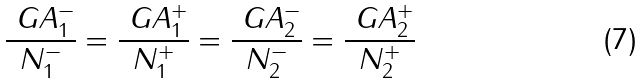Convert formula to latex. <formula><loc_0><loc_0><loc_500><loc_500>\frac { \ G A _ { 1 } ^ { - } } { N _ { 1 } ^ { - } } = \frac { \ G A _ { 1 } ^ { + } } { N _ { 1 } ^ { + } } = \frac { \ G A _ { 2 } ^ { - } } { N _ { 2 } ^ { - } } = \frac { \ G A _ { 2 } ^ { + } } { N _ { 2 } ^ { + } }</formula> 